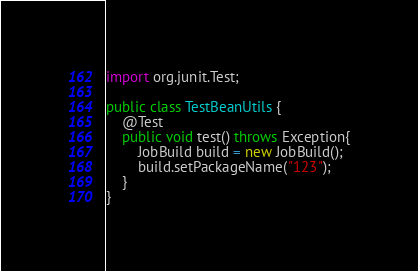<code> <loc_0><loc_0><loc_500><loc_500><_Java_>import org.junit.Test;

public class TestBeanUtils {
    @Test
    public void test() throws Exception{
        JobBuild build = new JobBuild();
        build.setPackageName("123");
    }
}
</code> 